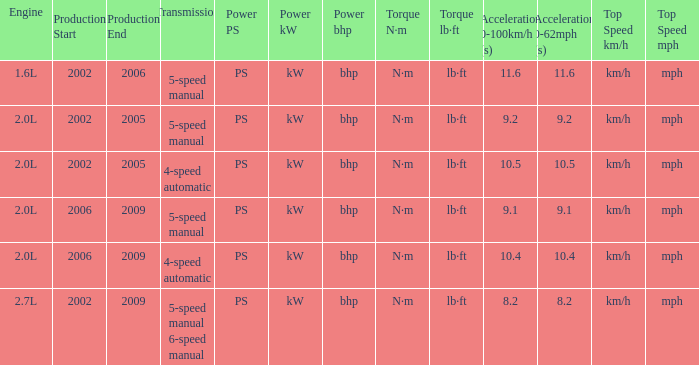What is the top speed of a 4-speed automatic with production in 2002-2005? Km/h (mph). 